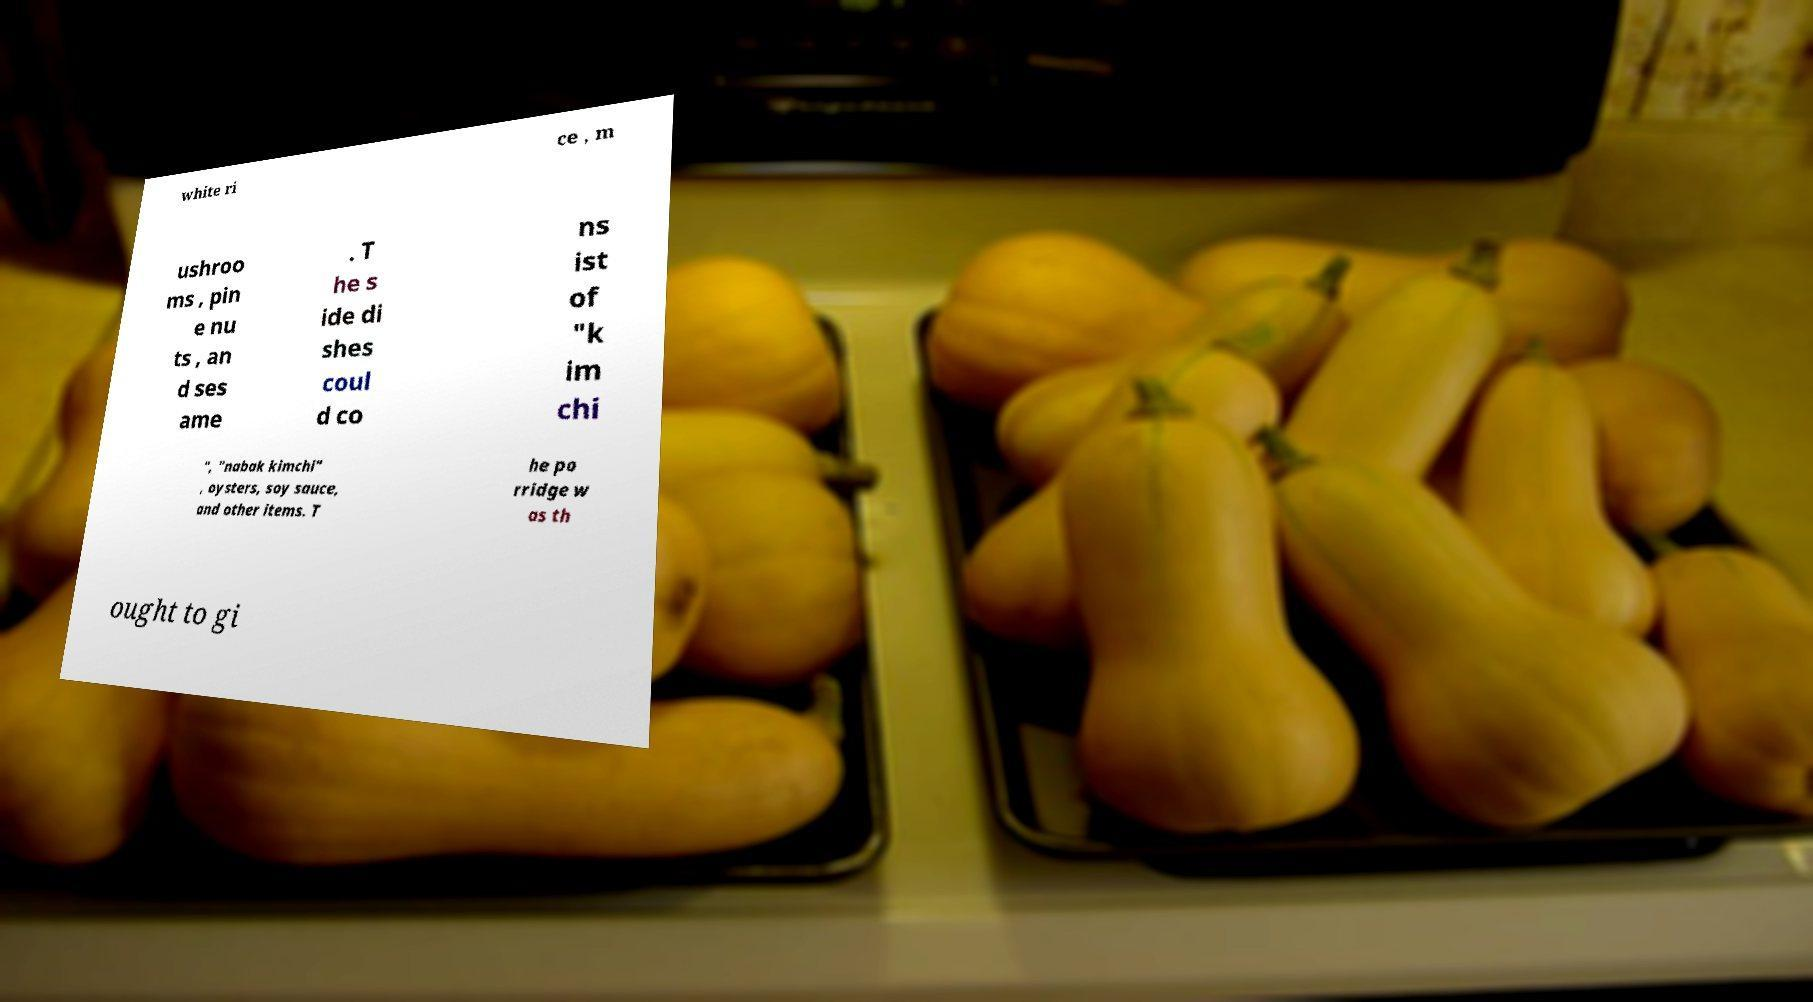What messages or text are displayed in this image? I need them in a readable, typed format. white ri ce , m ushroo ms , pin e nu ts , an d ses ame . T he s ide di shes coul d co ns ist of "k im chi ", "nabak kimchi" , oysters, soy sauce, and other items. T he po rridge w as th ought to gi 